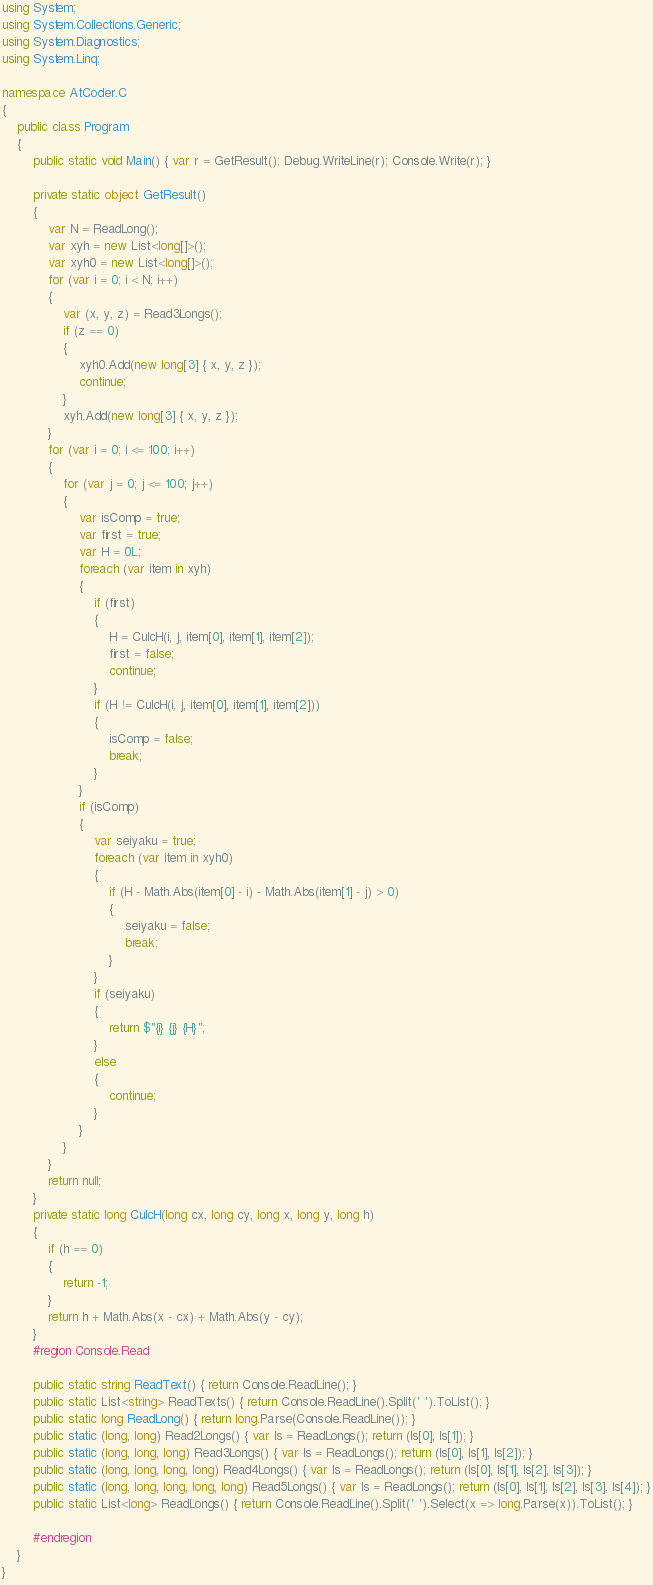Convert code to text. <code><loc_0><loc_0><loc_500><loc_500><_C#_>using System;
using System.Collections.Generic;
using System.Diagnostics;
using System.Linq;

namespace AtCoder.C
{
    public class Program
    {
        public static void Main() { var r = GetResult(); Debug.WriteLine(r); Console.Write(r); }

        private static object GetResult()
        {
            var N = ReadLong();
            var xyh = new List<long[]>();
            var xyh0 = new List<long[]>();
            for (var i = 0; i < N; i++)
            {
                var (x, y, z) = Read3Longs();
                if (z == 0)
                {
                    xyh0.Add(new long[3] { x, y, z });
                    continue;
                }
                xyh.Add(new long[3] { x, y, z });
            }
            for (var i = 0; i <= 100; i++)
            {
                for (var j = 0; j <= 100; j++)
                {
                    var isComp = true;
                    var first = true;
                    var H = 0L;
                    foreach (var item in xyh)
                    {
                        if (first)
                        {
                            H = CulcH(i, j, item[0], item[1], item[2]);
                            first = false;
                            continue;
                        }
                        if (H != CulcH(i, j, item[0], item[1], item[2]))
                        {
                            isComp = false;
                            break;
                        }
                    }
                    if (isComp)
                    {
                        var seiyaku = true;
                        foreach (var item in xyh0)
                        {
                            if (H - Math.Abs(item[0] - i) - Math.Abs(item[1] - j) > 0)
                            {
                                seiyaku = false;
                                break;
                            }
                        }
                        if (seiyaku)
                        {
                            return $"{i} {j} {H}";
                        }
                        else
                        {
                            continue;
                        }
                    }
                }
            }
            return null;
        }
        private static long CulcH(long cx, long cy, long x, long y, long h)
        {
            if (h == 0)
            {
                return -1;
            }
            return h + Math.Abs(x - cx) + Math.Abs(y - cy);
        }
        #region Console.Read

        public static string ReadText() { return Console.ReadLine(); }
        public static List<string> ReadTexts() { return Console.ReadLine().Split(' ').ToList(); }
        public static long ReadLong() { return long.Parse(Console.ReadLine()); }
        public static (long, long) Read2Longs() { var ls = ReadLongs(); return (ls[0], ls[1]); }
        public static (long, long, long) Read3Longs() { var ls = ReadLongs(); return (ls[0], ls[1], ls[2]); }
        public static (long, long, long, long) Read4Longs() { var ls = ReadLongs(); return (ls[0], ls[1], ls[2], ls[3]); }
        public static (long, long, long, long, long) Read5Longs() { var ls = ReadLongs(); return (ls[0], ls[1], ls[2], ls[3], ls[4]); }
        public static List<long> ReadLongs() { return Console.ReadLine().Split(' ').Select(x => long.Parse(x)).ToList(); }

        #endregion
    }
}
</code> 